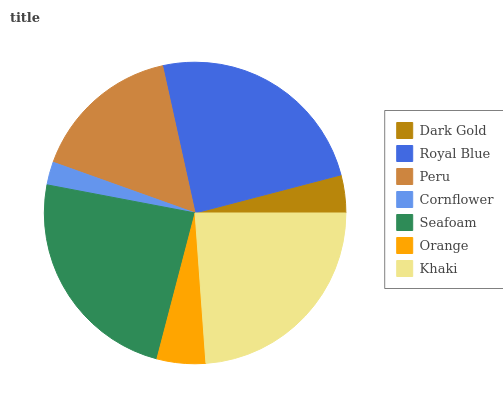Is Cornflower the minimum?
Answer yes or no. Yes. Is Royal Blue the maximum?
Answer yes or no. Yes. Is Peru the minimum?
Answer yes or no. No. Is Peru the maximum?
Answer yes or no. No. Is Royal Blue greater than Peru?
Answer yes or no. Yes. Is Peru less than Royal Blue?
Answer yes or no. Yes. Is Peru greater than Royal Blue?
Answer yes or no. No. Is Royal Blue less than Peru?
Answer yes or no. No. Is Peru the high median?
Answer yes or no. Yes. Is Peru the low median?
Answer yes or no. Yes. Is Seafoam the high median?
Answer yes or no. No. Is Khaki the low median?
Answer yes or no. No. 